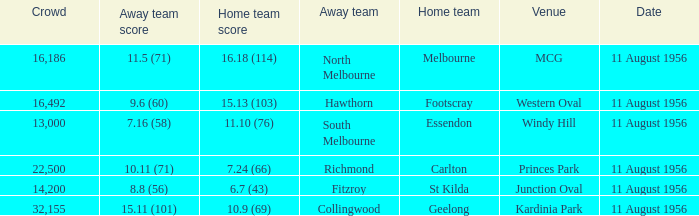What domestic team competed at the western oval? Footscray. 